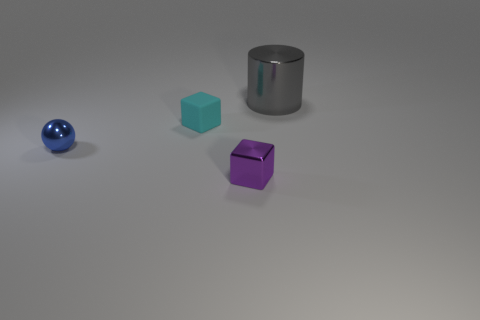Is there anything else that has the same material as the cyan block?
Provide a succinct answer. No. What shape is the small metal thing that is in front of the small metal sphere?
Your response must be concise. Cube. There is a cylinder; is its color the same as the block that is behind the purple metallic thing?
Ensure brevity in your answer.  No. Are there an equal number of tiny blue metallic spheres that are behind the big metallic cylinder and small rubber cubes that are in front of the blue ball?
Provide a short and direct response. Yes. How many other things are there of the same size as the rubber cube?
Your answer should be very brief. 2. The gray metal thing has what size?
Provide a succinct answer. Large. Does the sphere have the same material as the tiny thing that is behind the small blue object?
Make the answer very short. No. Is there another gray metallic object of the same shape as the big metallic thing?
Make the answer very short. No. What is the material of the blue ball that is the same size as the purple thing?
Keep it short and to the point. Metal. There is a cube that is in front of the tiny metal ball; what is its size?
Your answer should be compact. Small. 